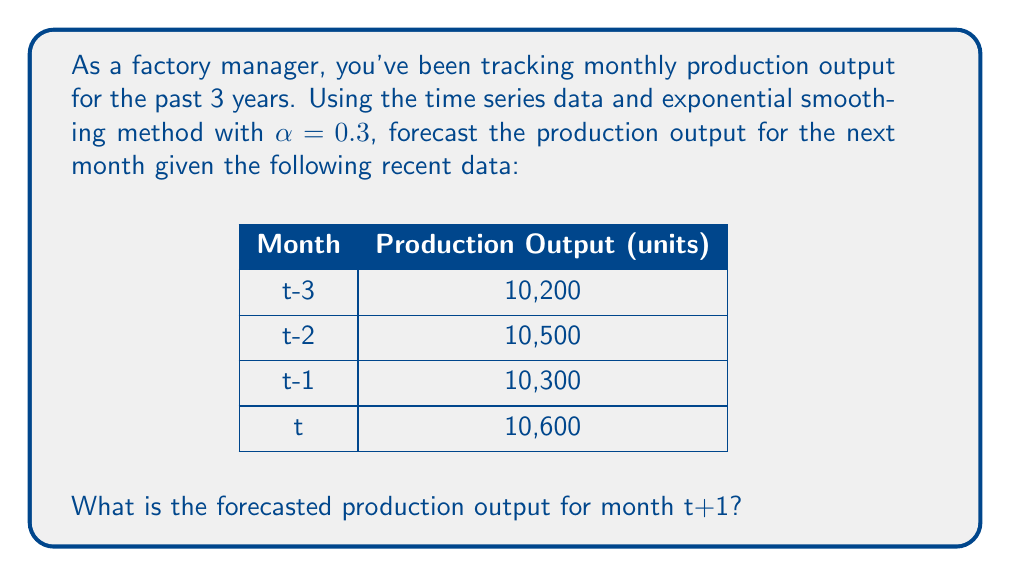What is the answer to this math problem? To forecast the production output using exponential smoothing, we'll use the formula:

$$F_{t+1} = \alpha Y_t + (1-\alpha)F_t$$

Where:
$F_{t+1}$ is the forecast for the next period
$\alpha$ is the smoothing constant (given as 0.3)
$Y_t$ is the actual value at time t
$F_t$ is the forecast for the current period

We need to calculate the forecasts for each period, starting from t-2:

1. For t-2:
   $F_{t-2} = 10,200$ (assuming the previous forecast equals the actual value)

2. For t-1:
   $$F_{t-1} = 0.3(10,500) + 0.7(10,200) = 3,150 + 7,140 = 10,290$$

3. For t:
   $$F_t = 0.3(10,300) + 0.7(10,290) = 3,090 + 7,203 = 10,293$$

4. For t+1 (our target forecast):
   $$F_{t+1} = 0.3(10,600) + 0.7(10,293) = 3,180 + 7,205.1 = 10,385.1$$

Therefore, the forecasted production output for month t+1 is 10,385.1 units.
Answer: 10,385 units (rounded to the nearest whole unit) 